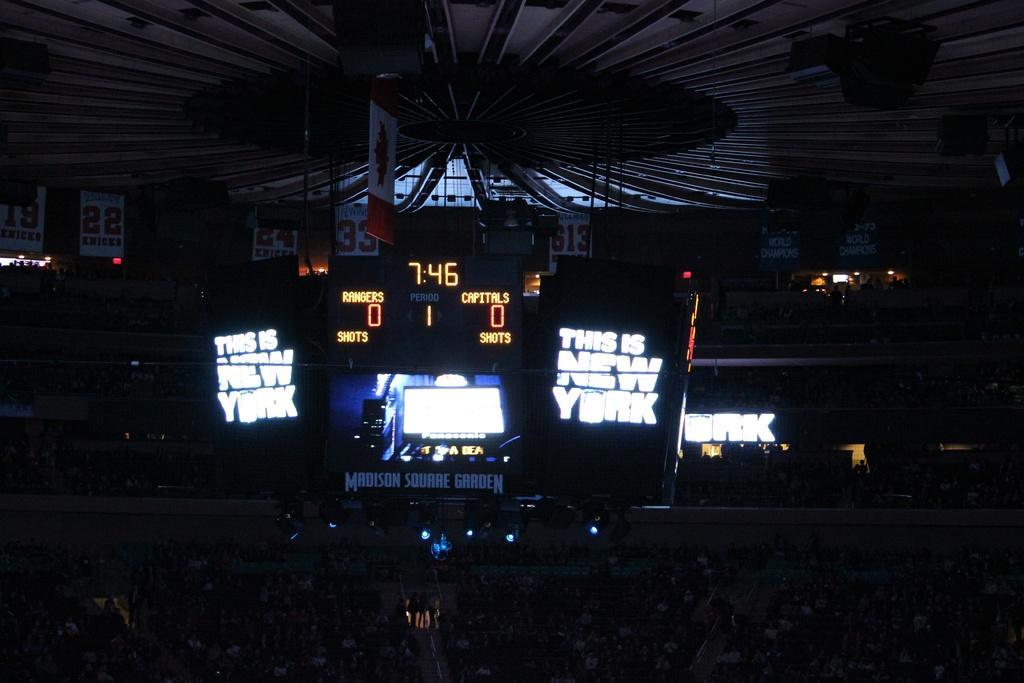Please provide a concise description of this image. This image is taken in a stadium. In this image we can see many people sitting. We can also see a few people standing. Image also consists of a display screen, score board with time and score, text boards, banners, number boards. At the top we can see the roof. 